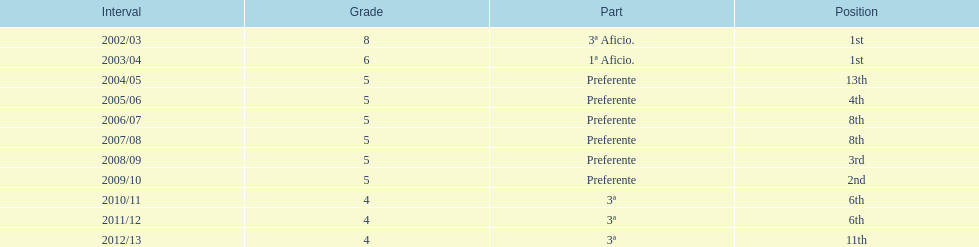Which division placed more than aficio 1a and 3a? Preferente. 